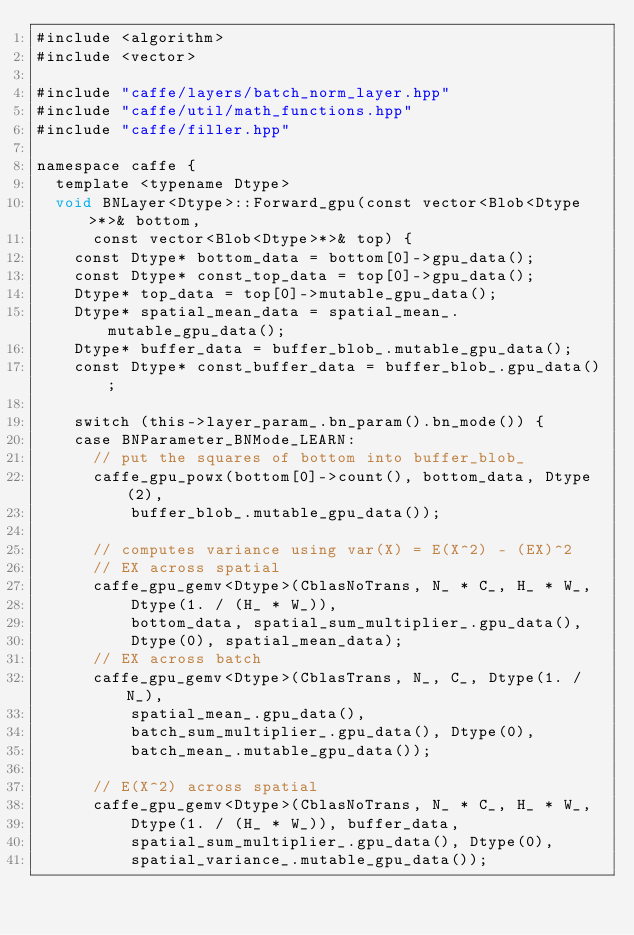Convert code to text. <code><loc_0><loc_0><loc_500><loc_500><_Cuda_>#include <algorithm>
#include <vector>

#include "caffe/layers/batch_norm_layer.hpp"
#include "caffe/util/math_functions.hpp"
#include "caffe/filler.hpp"

namespace caffe {
  template <typename Dtype>
  void BNLayer<Dtype>::Forward_gpu(const vector<Blob<Dtype>*>& bottom,
      const vector<Blob<Dtype>*>& top) {
    const Dtype* bottom_data = bottom[0]->gpu_data();
    const Dtype* const_top_data = top[0]->gpu_data();
    Dtype* top_data = top[0]->mutable_gpu_data();
    Dtype* spatial_mean_data = spatial_mean_.mutable_gpu_data();
    Dtype* buffer_data = buffer_blob_.mutable_gpu_data();
    const Dtype* const_buffer_data = buffer_blob_.gpu_data();

    switch (this->layer_param_.bn_param().bn_mode()) {
    case BNParameter_BNMode_LEARN:
      // put the squares of bottom into buffer_blob_
      caffe_gpu_powx(bottom[0]->count(), bottom_data, Dtype(2),
          buffer_blob_.mutable_gpu_data());

      // computes variance using var(X) = E(X^2) - (EX)^2
      // EX across spatial
      caffe_gpu_gemv<Dtype>(CblasNoTrans, N_ * C_, H_ * W_,
          Dtype(1. / (H_ * W_)),
          bottom_data, spatial_sum_multiplier_.gpu_data(),
          Dtype(0), spatial_mean_data);
      // EX across batch
      caffe_gpu_gemv<Dtype>(CblasTrans, N_, C_, Dtype(1. / N_),
          spatial_mean_.gpu_data(),
          batch_sum_multiplier_.gpu_data(), Dtype(0),
          batch_mean_.mutable_gpu_data());

      // E(X^2) across spatial
      caffe_gpu_gemv<Dtype>(CblasNoTrans, N_ * C_, H_ * W_,
          Dtype(1. / (H_ * W_)), buffer_data,
          spatial_sum_multiplier_.gpu_data(), Dtype(0),
          spatial_variance_.mutable_gpu_data());</code> 